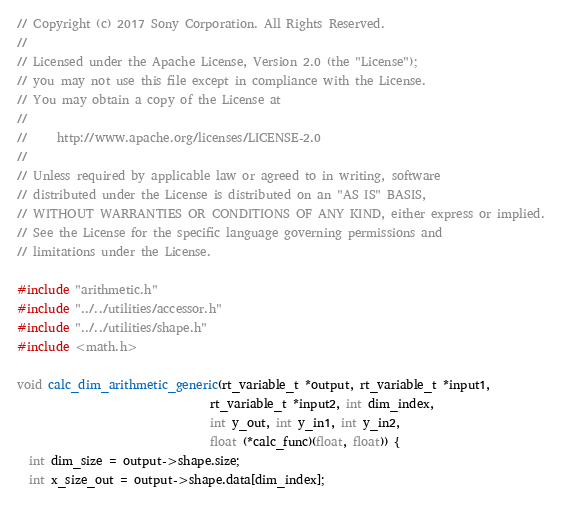<code> <loc_0><loc_0><loc_500><loc_500><_C_>// Copyright (c) 2017 Sony Corporation. All Rights Reserved.
//
// Licensed under the Apache License, Version 2.0 (the "License");
// you may not use this file except in compliance with the License.
// You may obtain a copy of the License at
//
//     http://www.apache.org/licenses/LICENSE-2.0
//
// Unless required by applicable law or agreed to in writing, software
// distributed under the License is distributed on an "AS IS" BASIS,
// WITHOUT WARRANTIES OR CONDITIONS OF ANY KIND, either express or implied.
// See the License for the specific language governing permissions and
// limitations under the License.

#include "arithmetic.h"
#include "../../utilities/accessor.h"
#include "../../utilities/shape.h"
#include <math.h>

void calc_dim_arithmetic_generic(rt_variable_t *output, rt_variable_t *input1,
                                 rt_variable_t *input2, int dim_index,
                                 int y_out, int y_in1, int y_in2,
                                 float (*calc_func)(float, float)) {
  int dim_size = output->shape.size;
  int x_size_out = output->shape.data[dim_index];</code> 